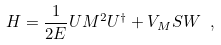Convert formula to latex. <formula><loc_0><loc_0><loc_500><loc_500>H = \frac { 1 } { 2 E } U M ^ { 2 } U ^ { \dagger } + V _ { M } S W \ ,</formula> 